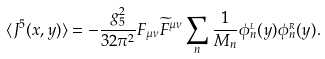Convert formula to latex. <formula><loc_0><loc_0><loc_500><loc_500>\langle J ^ { 5 } ( x , y ) \rangle = - \frac { g _ { 5 } ^ { 2 } } { 3 2 \pi ^ { 2 } } F _ { \mu \nu } \widetilde { F } ^ { \mu \nu } \sum _ { n } \frac { 1 } { M _ { n } } \phi _ { n } ^ { _ { L } } ( y ) \phi _ { n } ^ { _ { R } } ( y ) .</formula> 